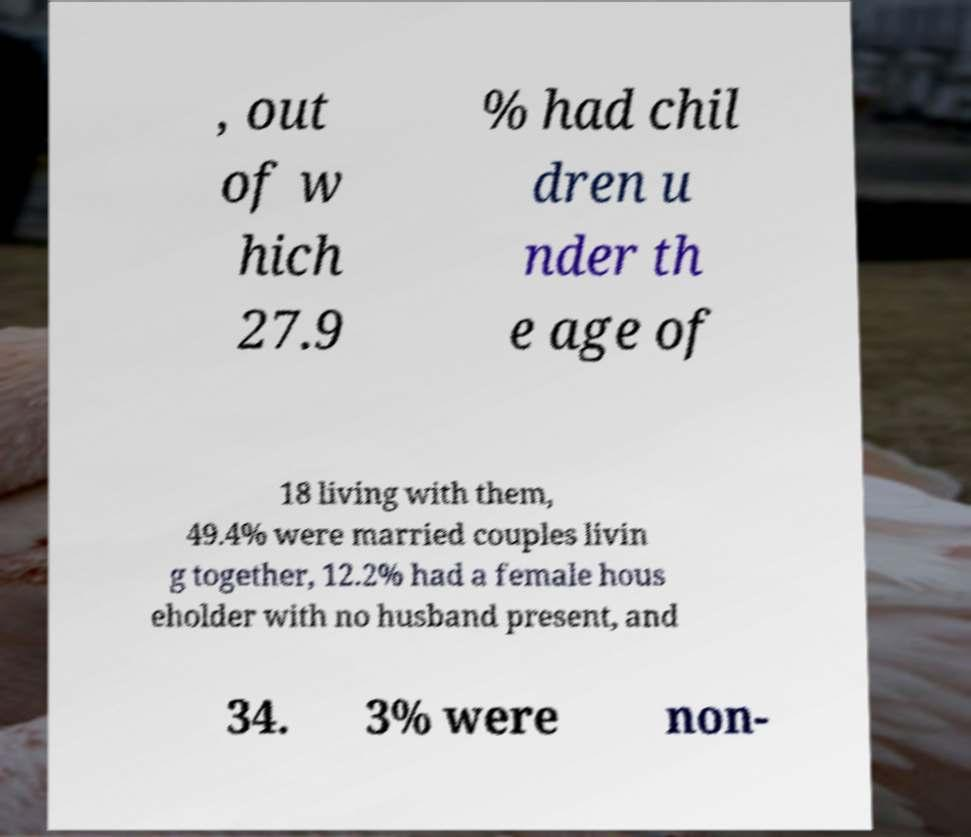Please read and relay the text visible in this image. What does it say? , out of w hich 27.9 % had chil dren u nder th e age of 18 living with them, 49.4% were married couples livin g together, 12.2% had a female hous eholder with no husband present, and 34. 3% were non- 